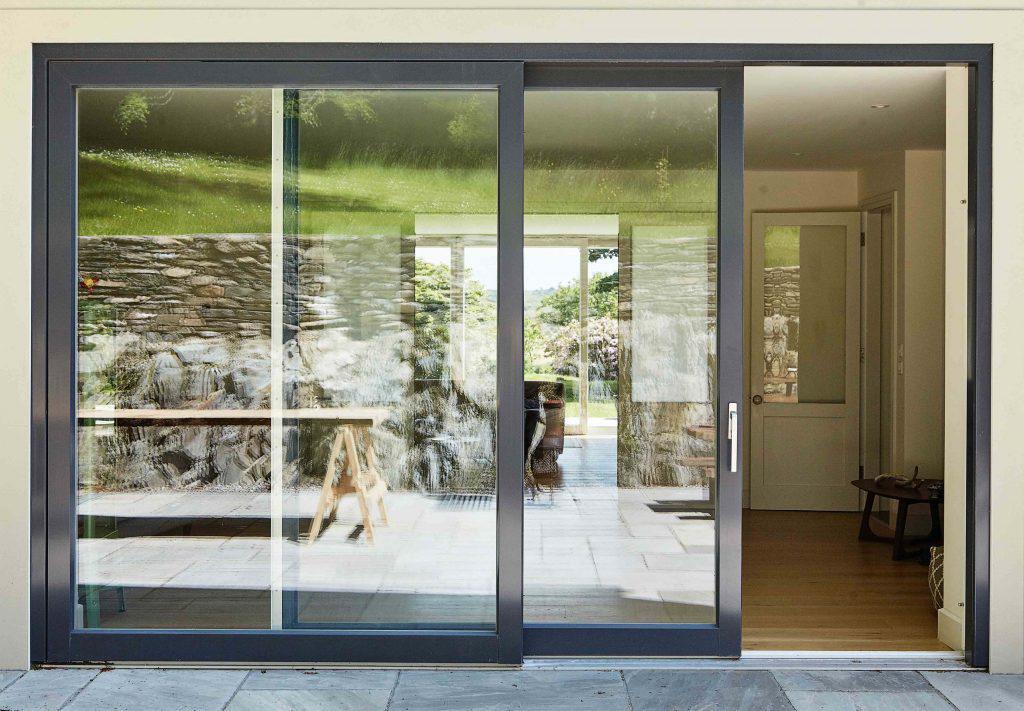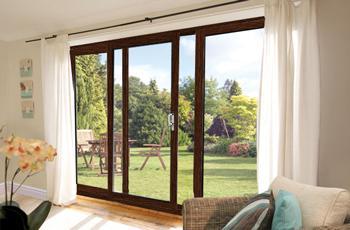The first image is the image on the left, the second image is the image on the right. Assess this claim about the two images: "The doors in the right image are open.". Correct or not? Answer yes or no. Yes. The first image is the image on the left, the second image is the image on the right. Analyze the images presented: Is the assertion "There are three wooden framed glass panel and at least one full set is closed." valid? Answer yes or no. No. 